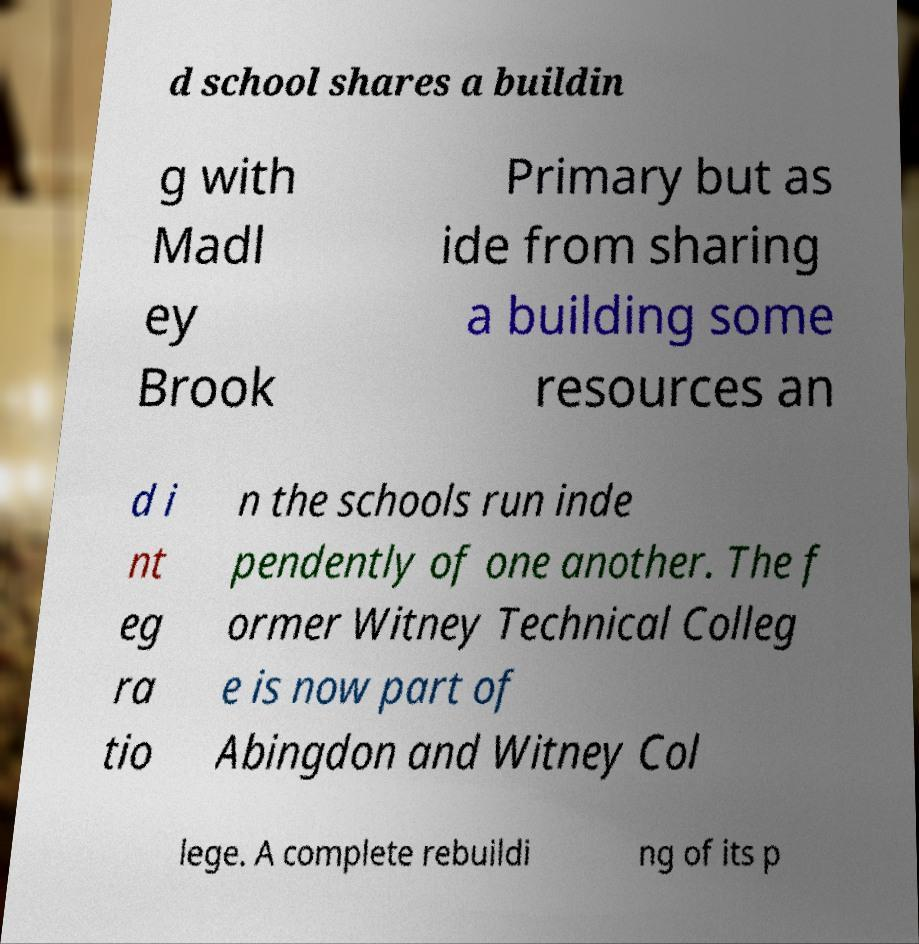For documentation purposes, I need the text within this image transcribed. Could you provide that? d school shares a buildin g with Madl ey Brook Primary but as ide from sharing a building some resources an d i nt eg ra tio n the schools run inde pendently of one another. The f ormer Witney Technical Colleg e is now part of Abingdon and Witney Col lege. A complete rebuildi ng of its p 